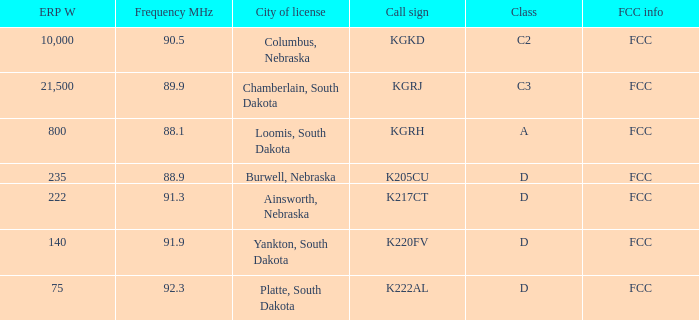What is the average frequency mhz of the loomis, south dakota city license? 88.1. 